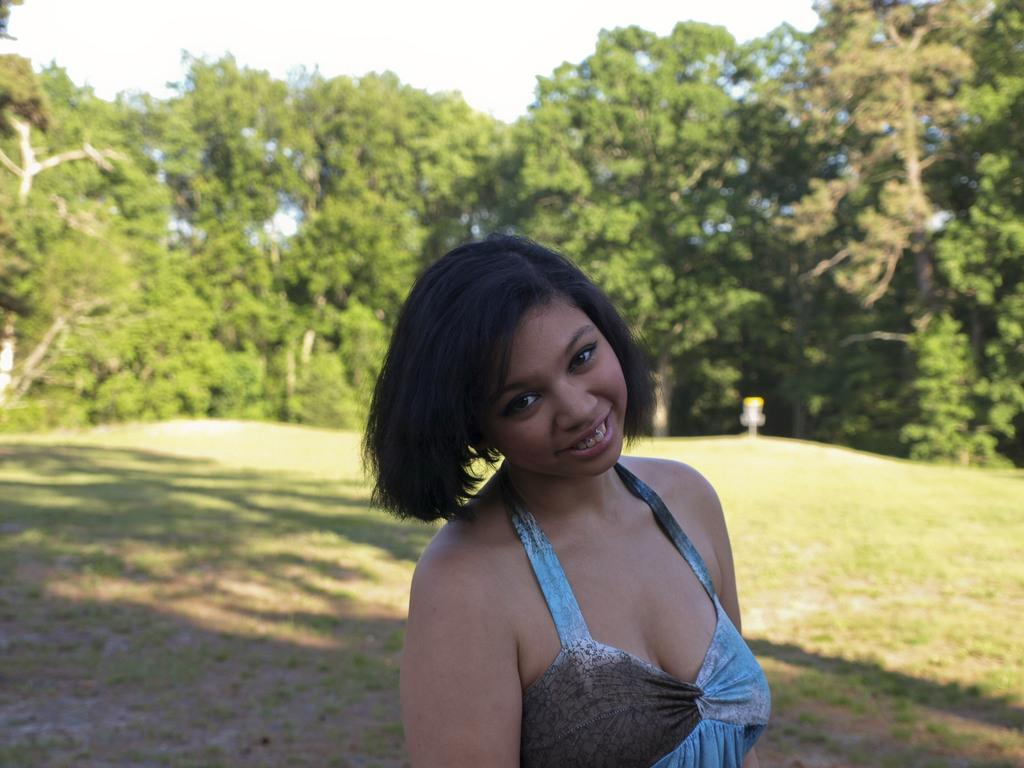What type of setting is depicted in the image? The image has an outside view. Can you describe the person in the foreground of the image? There is a person in the foreground of the image. What is the person wearing? The person is wearing clothes. What can be seen in the background of the image? There are trees in the background of the image. What type of prose can be heard being read by the person in the image? There is no indication in the image that the person is reading or speaking, so it cannot be determined what type of prose might be heard. 